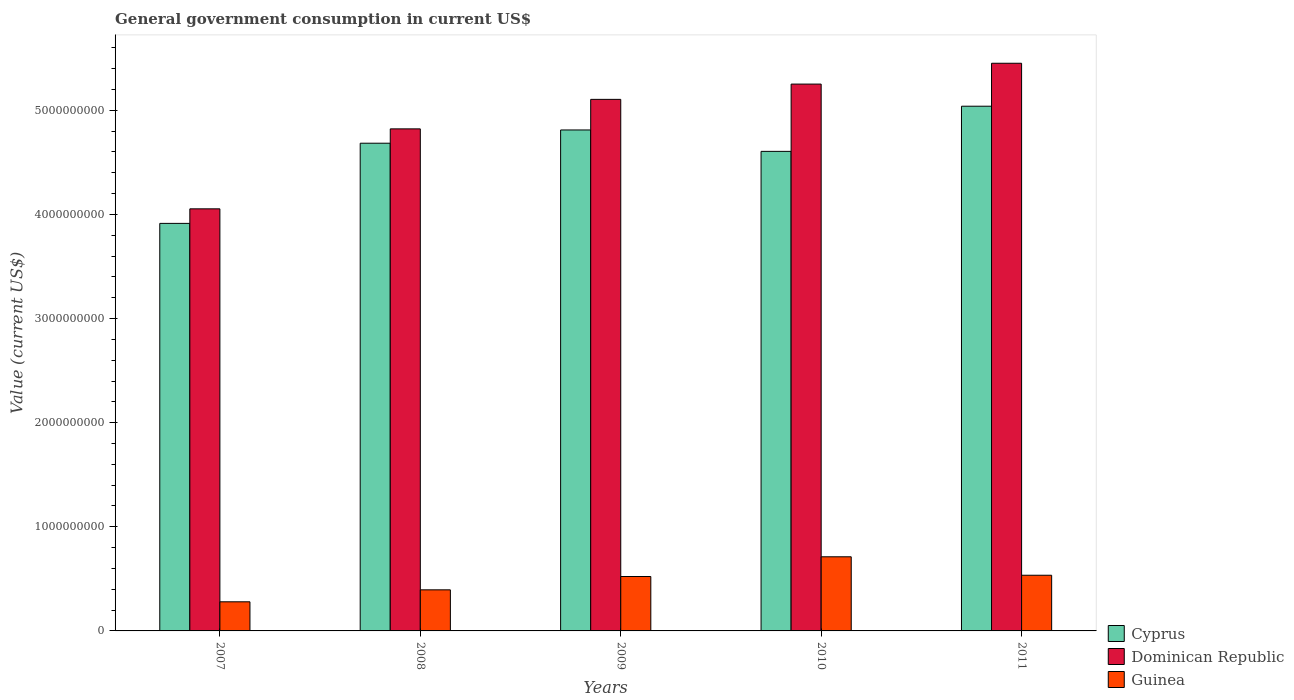Are the number of bars per tick equal to the number of legend labels?
Your answer should be compact. Yes. How many bars are there on the 5th tick from the left?
Offer a terse response. 3. How many bars are there on the 3rd tick from the right?
Keep it short and to the point. 3. In how many cases, is the number of bars for a given year not equal to the number of legend labels?
Offer a terse response. 0. What is the government conusmption in Dominican Republic in 2011?
Provide a short and direct response. 5.45e+09. Across all years, what is the maximum government conusmption in Guinea?
Keep it short and to the point. 7.12e+08. Across all years, what is the minimum government conusmption in Dominican Republic?
Make the answer very short. 4.05e+09. In which year was the government conusmption in Guinea minimum?
Offer a terse response. 2007. What is the total government conusmption in Dominican Republic in the graph?
Offer a very short reply. 2.47e+1. What is the difference between the government conusmption in Cyprus in 2009 and that in 2011?
Offer a terse response. -2.28e+08. What is the difference between the government conusmption in Dominican Republic in 2008 and the government conusmption in Guinea in 2007?
Give a very brief answer. 4.54e+09. What is the average government conusmption in Cyprus per year?
Offer a very short reply. 4.61e+09. In the year 2009, what is the difference between the government conusmption in Dominican Republic and government conusmption in Cyprus?
Your answer should be very brief. 2.94e+08. In how many years, is the government conusmption in Cyprus greater than 3200000000 US$?
Your response must be concise. 5. What is the ratio of the government conusmption in Dominican Republic in 2007 to that in 2010?
Ensure brevity in your answer.  0.77. Is the government conusmption in Guinea in 2007 less than that in 2011?
Offer a terse response. Yes. What is the difference between the highest and the second highest government conusmption in Cyprus?
Your answer should be very brief. 2.28e+08. What is the difference between the highest and the lowest government conusmption in Cyprus?
Provide a succinct answer. 1.13e+09. Is the sum of the government conusmption in Dominican Republic in 2007 and 2011 greater than the maximum government conusmption in Cyprus across all years?
Your answer should be compact. Yes. What does the 1st bar from the left in 2007 represents?
Your answer should be very brief. Cyprus. What does the 2nd bar from the right in 2011 represents?
Provide a succinct answer. Dominican Republic. Is it the case that in every year, the sum of the government conusmption in Cyprus and government conusmption in Guinea is greater than the government conusmption in Dominican Republic?
Ensure brevity in your answer.  Yes. How many bars are there?
Offer a very short reply. 15. What is the difference between two consecutive major ticks on the Y-axis?
Provide a short and direct response. 1.00e+09. Where does the legend appear in the graph?
Offer a very short reply. Bottom right. What is the title of the graph?
Your answer should be compact. General government consumption in current US$. Does "Least developed countries" appear as one of the legend labels in the graph?
Offer a very short reply. No. What is the label or title of the Y-axis?
Give a very brief answer. Value (current US$). What is the Value (current US$) of Cyprus in 2007?
Offer a very short reply. 3.91e+09. What is the Value (current US$) in Dominican Republic in 2007?
Give a very brief answer. 4.05e+09. What is the Value (current US$) in Guinea in 2007?
Keep it short and to the point. 2.80e+08. What is the Value (current US$) in Cyprus in 2008?
Offer a terse response. 4.68e+09. What is the Value (current US$) in Dominican Republic in 2008?
Your response must be concise. 4.82e+09. What is the Value (current US$) in Guinea in 2008?
Your answer should be very brief. 3.95e+08. What is the Value (current US$) of Cyprus in 2009?
Your response must be concise. 4.81e+09. What is the Value (current US$) of Dominican Republic in 2009?
Provide a succinct answer. 5.10e+09. What is the Value (current US$) in Guinea in 2009?
Offer a very short reply. 5.22e+08. What is the Value (current US$) of Cyprus in 2010?
Your answer should be compact. 4.61e+09. What is the Value (current US$) in Dominican Republic in 2010?
Provide a short and direct response. 5.25e+09. What is the Value (current US$) in Guinea in 2010?
Keep it short and to the point. 7.12e+08. What is the Value (current US$) in Cyprus in 2011?
Your answer should be very brief. 5.04e+09. What is the Value (current US$) of Dominican Republic in 2011?
Your answer should be compact. 5.45e+09. What is the Value (current US$) in Guinea in 2011?
Give a very brief answer. 5.35e+08. Across all years, what is the maximum Value (current US$) in Cyprus?
Offer a very short reply. 5.04e+09. Across all years, what is the maximum Value (current US$) in Dominican Republic?
Provide a short and direct response. 5.45e+09. Across all years, what is the maximum Value (current US$) in Guinea?
Offer a terse response. 7.12e+08. Across all years, what is the minimum Value (current US$) in Cyprus?
Offer a very short reply. 3.91e+09. Across all years, what is the minimum Value (current US$) of Dominican Republic?
Provide a short and direct response. 4.05e+09. Across all years, what is the minimum Value (current US$) of Guinea?
Your answer should be very brief. 2.80e+08. What is the total Value (current US$) of Cyprus in the graph?
Offer a very short reply. 2.31e+1. What is the total Value (current US$) in Dominican Republic in the graph?
Make the answer very short. 2.47e+1. What is the total Value (current US$) in Guinea in the graph?
Offer a terse response. 2.44e+09. What is the difference between the Value (current US$) in Cyprus in 2007 and that in 2008?
Offer a terse response. -7.70e+08. What is the difference between the Value (current US$) of Dominican Republic in 2007 and that in 2008?
Ensure brevity in your answer.  -7.68e+08. What is the difference between the Value (current US$) in Guinea in 2007 and that in 2008?
Ensure brevity in your answer.  -1.15e+08. What is the difference between the Value (current US$) of Cyprus in 2007 and that in 2009?
Keep it short and to the point. -8.97e+08. What is the difference between the Value (current US$) of Dominican Republic in 2007 and that in 2009?
Offer a terse response. -1.05e+09. What is the difference between the Value (current US$) in Guinea in 2007 and that in 2009?
Provide a short and direct response. -2.43e+08. What is the difference between the Value (current US$) of Cyprus in 2007 and that in 2010?
Ensure brevity in your answer.  -6.92e+08. What is the difference between the Value (current US$) of Dominican Republic in 2007 and that in 2010?
Your answer should be compact. -1.20e+09. What is the difference between the Value (current US$) in Guinea in 2007 and that in 2010?
Your answer should be compact. -4.32e+08. What is the difference between the Value (current US$) in Cyprus in 2007 and that in 2011?
Offer a very short reply. -1.13e+09. What is the difference between the Value (current US$) in Dominican Republic in 2007 and that in 2011?
Provide a succinct answer. -1.40e+09. What is the difference between the Value (current US$) of Guinea in 2007 and that in 2011?
Give a very brief answer. -2.55e+08. What is the difference between the Value (current US$) of Cyprus in 2008 and that in 2009?
Your answer should be very brief. -1.27e+08. What is the difference between the Value (current US$) of Dominican Republic in 2008 and that in 2009?
Ensure brevity in your answer.  -2.83e+08. What is the difference between the Value (current US$) in Guinea in 2008 and that in 2009?
Keep it short and to the point. -1.28e+08. What is the difference between the Value (current US$) in Cyprus in 2008 and that in 2010?
Provide a succinct answer. 7.84e+07. What is the difference between the Value (current US$) in Dominican Republic in 2008 and that in 2010?
Keep it short and to the point. -4.30e+08. What is the difference between the Value (current US$) of Guinea in 2008 and that in 2010?
Provide a short and direct response. -3.17e+08. What is the difference between the Value (current US$) of Cyprus in 2008 and that in 2011?
Provide a short and direct response. -3.55e+08. What is the difference between the Value (current US$) of Dominican Republic in 2008 and that in 2011?
Offer a terse response. -6.30e+08. What is the difference between the Value (current US$) in Guinea in 2008 and that in 2011?
Your response must be concise. -1.40e+08. What is the difference between the Value (current US$) in Cyprus in 2009 and that in 2010?
Ensure brevity in your answer.  2.06e+08. What is the difference between the Value (current US$) in Dominican Republic in 2009 and that in 2010?
Your response must be concise. -1.47e+08. What is the difference between the Value (current US$) of Guinea in 2009 and that in 2010?
Keep it short and to the point. -1.89e+08. What is the difference between the Value (current US$) in Cyprus in 2009 and that in 2011?
Your answer should be very brief. -2.28e+08. What is the difference between the Value (current US$) of Dominican Republic in 2009 and that in 2011?
Give a very brief answer. -3.47e+08. What is the difference between the Value (current US$) of Guinea in 2009 and that in 2011?
Your answer should be very brief. -1.23e+07. What is the difference between the Value (current US$) of Cyprus in 2010 and that in 2011?
Provide a short and direct response. -4.34e+08. What is the difference between the Value (current US$) of Dominican Republic in 2010 and that in 2011?
Ensure brevity in your answer.  -2.00e+08. What is the difference between the Value (current US$) of Guinea in 2010 and that in 2011?
Give a very brief answer. 1.77e+08. What is the difference between the Value (current US$) of Cyprus in 2007 and the Value (current US$) of Dominican Republic in 2008?
Keep it short and to the point. -9.08e+08. What is the difference between the Value (current US$) of Cyprus in 2007 and the Value (current US$) of Guinea in 2008?
Your response must be concise. 3.52e+09. What is the difference between the Value (current US$) of Dominican Republic in 2007 and the Value (current US$) of Guinea in 2008?
Give a very brief answer. 3.66e+09. What is the difference between the Value (current US$) in Cyprus in 2007 and the Value (current US$) in Dominican Republic in 2009?
Your answer should be very brief. -1.19e+09. What is the difference between the Value (current US$) of Cyprus in 2007 and the Value (current US$) of Guinea in 2009?
Your answer should be compact. 3.39e+09. What is the difference between the Value (current US$) of Dominican Republic in 2007 and the Value (current US$) of Guinea in 2009?
Provide a succinct answer. 3.53e+09. What is the difference between the Value (current US$) in Cyprus in 2007 and the Value (current US$) in Dominican Republic in 2010?
Your answer should be compact. -1.34e+09. What is the difference between the Value (current US$) of Cyprus in 2007 and the Value (current US$) of Guinea in 2010?
Offer a very short reply. 3.20e+09. What is the difference between the Value (current US$) of Dominican Republic in 2007 and the Value (current US$) of Guinea in 2010?
Your response must be concise. 3.34e+09. What is the difference between the Value (current US$) of Cyprus in 2007 and the Value (current US$) of Dominican Republic in 2011?
Your response must be concise. -1.54e+09. What is the difference between the Value (current US$) in Cyprus in 2007 and the Value (current US$) in Guinea in 2011?
Ensure brevity in your answer.  3.38e+09. What is the difference between the Value (current US$) in Dominican Republic in 2007 and the Value (current US$) in Guinea in 2011?
Offer a terse response. 3.52e+09. What is the difference between the Value (current US$) of Cyprus in 2008 and the Value (current US$) of Dominican Republic in 2009?
Offer a terse response. -4.21e+08. What is the difference between the Value (current US$) in Cyprus in 2008 and the Value (current US$) in Guinea in 2009?
Your answer should be compact. 4.16e+09. What is the difference between the Value (current US$) in Dominican Republic in 2008 and the Value (current US$) in Guinea in 2009?
Give a very brief answer. 4.30e+09. What is the difference between the Value (current US$) in Cyprus in 2008 and the Value (current US$) in Dominican Republic in 2010?
Provide a succinct answer. -5.68e+08. What is the difference between the Value (current US$) of Cyprus in 2008 and the Value (current US$) of Guinea in 2010?
Offer a very short reply. 3.97e+09. What is the difference between the Value (current US$) of Dominican Republic in 2008 and the Value (current US$) of Guinea in 2010?
Give a very brief answer. 4.11e+09. What is the difference between the Value (current US$) of Cyprus in 2008 and the Value (current US$) of Dominican Republic in 2011?
Your answer should be compact. -7.68e+08. What is the difference between the Value (current US$) in Cyprus in 2008 and the Value (current US$) in Guinea in 2011?
Ensure brevity in your answer.  4.15e+09. What is the difference between the Value (current US$) in Dominican Republic in 2008 and the Value (current US$) in Guinea in 2011?
Provide a short and direct response. 4.29e+09. What is the difference between the Value (current US$) of Cyprus in 2009 and the Value (current US$) of Dominican Republic in 2010?
Offer a terse response. -4.41e+08. What is the difference between the Value (current US$) of Cyprus in 2009 and the Value (current US$) of Guinea in 2010?
Your answer should be compact. 4.10e+09. What is the difference between the Value (current US$) in Dominican Republic in 2009 and the Value (current US$) in Guinea in 2010?
Ensure brevity in your answer.  4.39e+09. What is the difference between the Value (current US$) in Cyprus in 2009 and the Value (current US$) in Dominican Republic in 2011?
Keep it short and to the point. -6.41e+08. What is the difference between the Value (current US$) of Cyprus in 2009 and the Value (current US$) of Guinea in 2011?
Ensure brevity in your answer.  4.28e+09. What is the difference between the Value (current US$) in Dominican Republic in 2009 and the Value (current US$) in Guinea in 2011?
Provide a short and direct response. 4.57e+09. What is the difference between the Value (current US$) of Cyprus in 2010 and the Value (current US$) of Dominican Republic in 2011?
Offer a very short reply. -8.46e+08. What is the difference between the Value (current US$) of Cyprus in 2010 and the Value (current US$) of Guinea in 2011?
Give a very brief answer. 4.07e+09. What is the difference between the Value (current US$) in Dominican Republic in 2010 and the Value (current US$) in Guinea in 2011?
Provide a succinct answer. 4.72e+09. What is the average Value (current US$) of Cyprus per year?
Keep it short and to the point. 4.61e+09. What is the average Value (current US$) in Dominican Republic per year?
Give a very brief answer. 4.94e+09. What is the average Value (current US$) in Guinea per year?
Your answer should be compact. 4.89e+08. In the year 2007, what is the difference between the Value (current US$) in Cyprus and Value (current US$) in Dominican Republic?
Give a very brief answer. -1.40e+08. In the year 2007, what is the difference between the Value (current US$) in Cyprus and Value (current US$) in Guinea?
Offer a very short reply. 3.63e+09. In the year 2007, what is the difference between the Value (current US$) in Dominican Republic and Value (current US$) in Guinea?
Offer a very short reply. 3.77e+09. In the year 2008, what is the difference between the Value (current US$) of Cyprus and Value (current US$) of Dominican Republic?
Make the answer very short. -1.38e+08. In the year 2008, what is the difference between the Value (current US$) in Cyprus and Value (current US$) in Guinea?
Your answer should be compact. 4.29e+09. In the year 2008, what is the difference between the Value (current US$) of Dominican Republic and Value (current US$) of Guinea?
Your answer should be very brief. 4.43e+09. In the year 2009, what is the difference between the Value (current US$) in Cyprus and Value (current US$) in Dominican Republic?
Provide a succinct answer. -2.94e+08. In the year 2009, what is the difference between the Value (current US$) of Cyprus and Value (current US$) of Guinea?
Make the answer very short. 4.29e+09. In the year 2009, what is the difference between the Value (current US$) of Dominican Republic and Value (current US$) of Guinea?
Your answer should be very brief. 4.58e+09. In the year 2010, what is the difference between the Value (current US$) of Cyprus and Value (current US$) of Dominican Republic?
Your response must be concise. -6.46e+08. In the year 2010, what is the difference between the Value (current US$) in Cyprus and Value (current US$) in Guinea?
Offer a terse response. 3.89e+09. In the year 2010, what is the difference between the Value (current US$) of Dominican Republic and Value (current US$) of Guinea?
Give a very brief answer. 4.54e+09. In the year 2011, what is the difference between the Value (current US$) in Cyprus and Value (current US$) in Dominican Republic?
Make the answer very short. -4.12e+08. In the year 2011, what is the difference between the Value (current US$) in Cyprus and Value (current US$) in Guinea?
Give a very brief answer. 4.50e+09. In the year 2011, what is the difference between the Value (current US$) in Dominican Republic and Value (current US$) in Guinea?
Provide a succinct answer. 4.92e+09. What is the ratio of the Value (current US$) in Cyprus in 2007 to that in 2008?
Your response must be concise. 0.84. What is the ratio of the Value (current US$) in Dominican Republic in 2007 to that in 2008?
Ensure brevity in your answer.  0.84. What is the ratio of the Value (current US$) of Guinea in 2007 to that in 2008?
Offer a very short reply. 0.71. What is the ratio of the Value (current US$) of Cyprus in 2007 to that in 2009?
Provide a succinct answer. 0.81. What is the ratio of the Value (current US$) in Dominican Republic in 2007 to that in 2009?
Offer a terse response. 0.79. What is the ratio of the Value (current US$) of Guinea in 2007 to that in 2009?
Give a very brief answer. 0.54. What is the ratio of the Value (current US$) in Cyprus in 2007 to that in 2010?
Your answer should be compact. 0.85. What is the ratio of the Value (current US$) of Dominican Republic in 2007 to that in 2010?
Offer a very short reply. 0.77. What is the ratio of the Value (current US$) of Guinea in 2007 to that in 2010?
Ensure brevity in your answer.  0.39. What is the ratio of the Value (current US$) of Cyprus in 2007 to that in 2011?
Make the answer very short. 0.78. What is the ratio of the Value (current US$) of Dominican Republic in 2007 to that in 2011?
Ensure brevity in your answer.  0.74. What is the ratio of the Value (current US$) in Guinea in 2007 to that in 2011?
Give a very brief answer. 0.52. What is the ratio of the Value (current US$) in Cyprus in 2008 to that in 2009?
Your answer should be compact. 0.97. What is the ratio of the Value (current US$) in Dominican Republic in 2008 to that in 2009?
Provide a short and direct response. 0.94. What is the ratio of the Value (current US$) of Guinea in 2008 to that in 2009?
Provide a succinct answer. 0.76. What is the ratio of the Value (current US$) of Cyprus in 2008 to that in 2010?
Give a very brief answer. 1.02. What is the ratio of the Value (current US$) in Dominican Republic in 2008 to that in 2010?
Keep it short and to the point. 0.92. What is the ratio of the Value (current US$) of Guinea in 2008 to that in 2010?
Ensure brevity in your answer.  0.55. What is the ratio of the Value (current US$) of Cyprus in 2008 to that in 2011?
Keep it short and to the point. 0.93. What is the ratio of the Value (current US$) in Dominican Republic in 2008 to that in 2011?
Ensure brevity in your answer.  0.88. What is the ratio of the Value (current US$) of Guinea in 2008 to that in 2011?
Make the answer very short. 0.74. What is the ratio of the Value (current US$) in Cyprus in 2009 to that in 2010?
Offer a terse response. 1.04. What is the ratio of the Value (current US$) in Dominican Republic in 2009 to that in 2010?
Ensure brevity in your answer.  0.97. What is the ratio of the Value (current US$) of Guinea in 2009 to that in 2010?
Provide a short and direct response. 0.73. What is the ratio of the Value (current US$) in Cyprus in 2009 to that in 2011?
Give a very brief answer. 0.95. What is the ratio of the Value (current US$) of Dominican Republic in 2009 to that in 2011?
Keep it short and to the point. 0.94. What is the ratio of the Value (current US$) in Guinea in 2009 to that in 2011?
Give a very brief answer. 0.98. What is the ratio of the Value (current US$) in Cyprus in 2010 to that in 2011?
Give a very brief answer. 0.91. What is the ratio of the Value (current US$) in Dominican Republic in 2010 to that in 2011?
Provide a short and direct response. 0.96. What is the ratio of the Value (current US$) in Guinea in 2010 to that in 2011?
Your answer should be compact. 1.33. What is the difference between the highest and the second highest Value (current US$) in Cyprus?
Keep it short and to the point. 2.28e+08. What is the difference between the highest and the second highest Value (current US$) of Dominican Republic?
Provide a short and direct response. 2.00e+08. What is the difference between the highest and the second highest Value (current US$) of Guinea?
Offer a very short reply. 1.77e+08. What is the difference between the highest and the lowest Value (current US$) in Cyprus?
Ensure brevity in your answer.  1.13e+09. What is the difference between the highest and the lowest Value (current US$) of Dominican Republic?
Give a very brief answer. 1.40e+09. What is the difference between the highest and the lowest Value (current US$) in Guinea?
Your answer should be compact. 4.32e+08. 